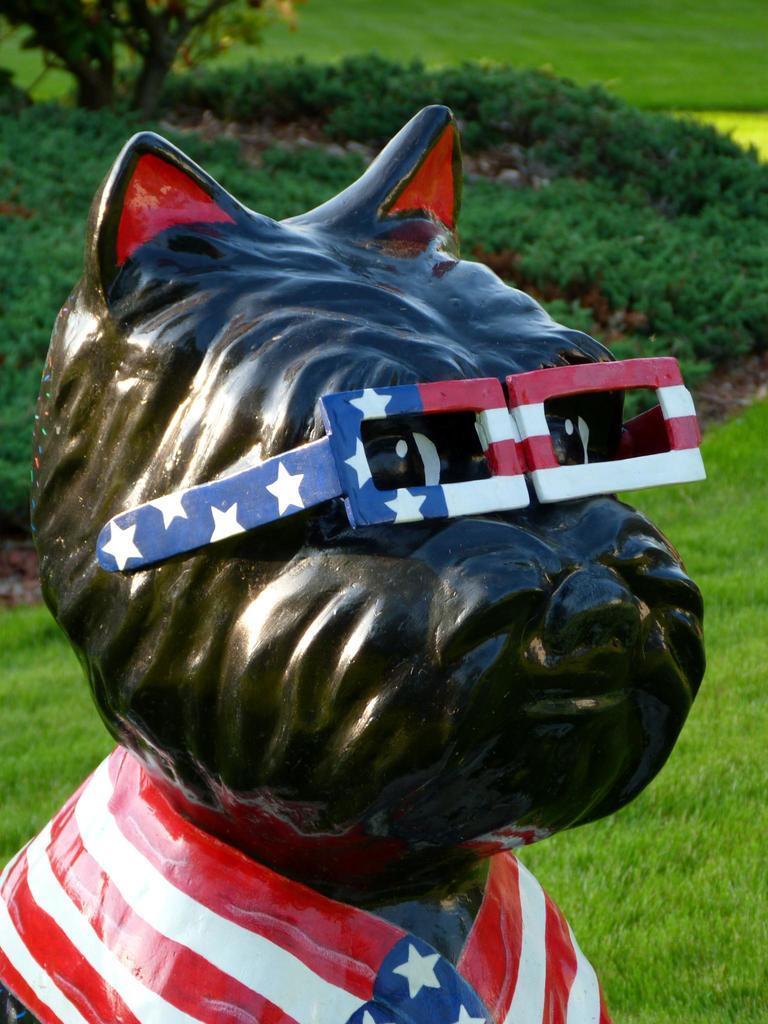Can you describe this image briefly? In the image I can see the sculpture of an animal who is wearing spectacles. In the background I can see the grass, plants and trees. 